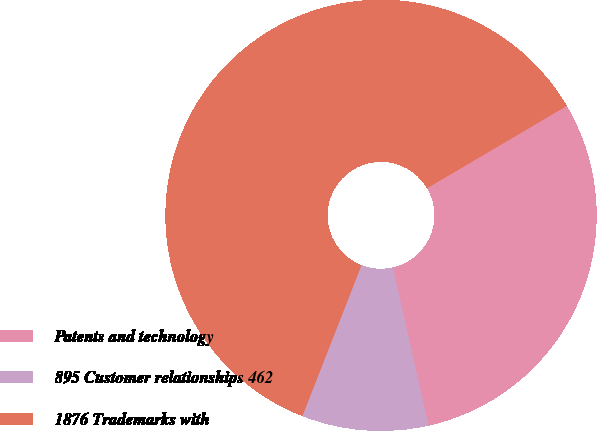Convert chart. <chart><loc_0><loc_0><loc_500><loc_500><pie_chart><fcel>Patents and technology<fcel>895 Customer relationships 462<fcel>1876 Trademarks with<nl><fcel>29.94%<fcel>9.48%<fcel>60.58%<nl></chart> 